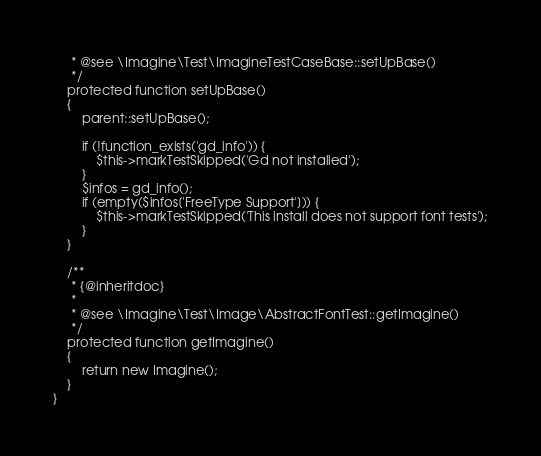Convert code to text. <code><loc_0><loc_0><loc_500><loc_500><_PHP_>     * @see \Imagine\Test\ImagineTestCaseBase::setUpBase()
     */
    protected function setUpBase()
    {
        parent::setUpBase();

        if (!function_exists('gd_info')) {
            $this->markTestSkipped('Gd not installed');
        }
        $infos = gd_info();
        if (empty($infos['FreeType Support'])) {
            $this->markTestSkipped('This install does not support font tests');
        }
    }

    /**
     * {@inheritdoc}
     *
     * @see \Imagine\Test\Image\AbstractFontTest::getImagine()
     */
    protected function getImagine()
    {
        return new Imagine();
    }
}
</code> 